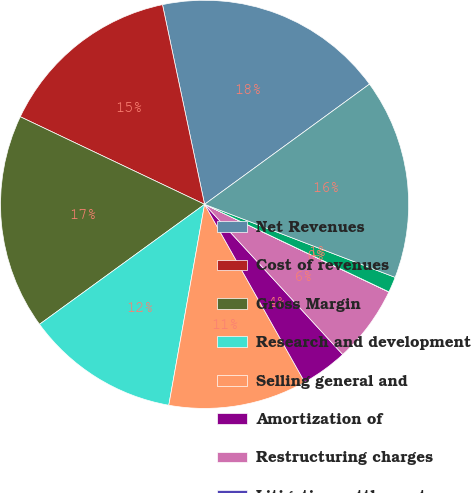Convert chart to OTSL. <chart><loc_0><loc_0><loc_500><loc_500><pie_chart><fcel>Net Revenues<fcel>Cost of revenues<fcel>Gross Margin<fcel>Research and development<fcel>Selling general and<fcel>Amortization of<fcel>Restructuring charges<fcel>Litigation settlement<fcel>Stock-based compensation<fcel>Total operating expenses<nl><fcel>18.28%<fcel>14.63%<fcel>17.06%<fcel>12.19%<fcel>10.97%<fcel>3.67%<fcel>6.1%<fcel>0.01%<fcel>1.23%<fcel>15.85%<nl></chart> 